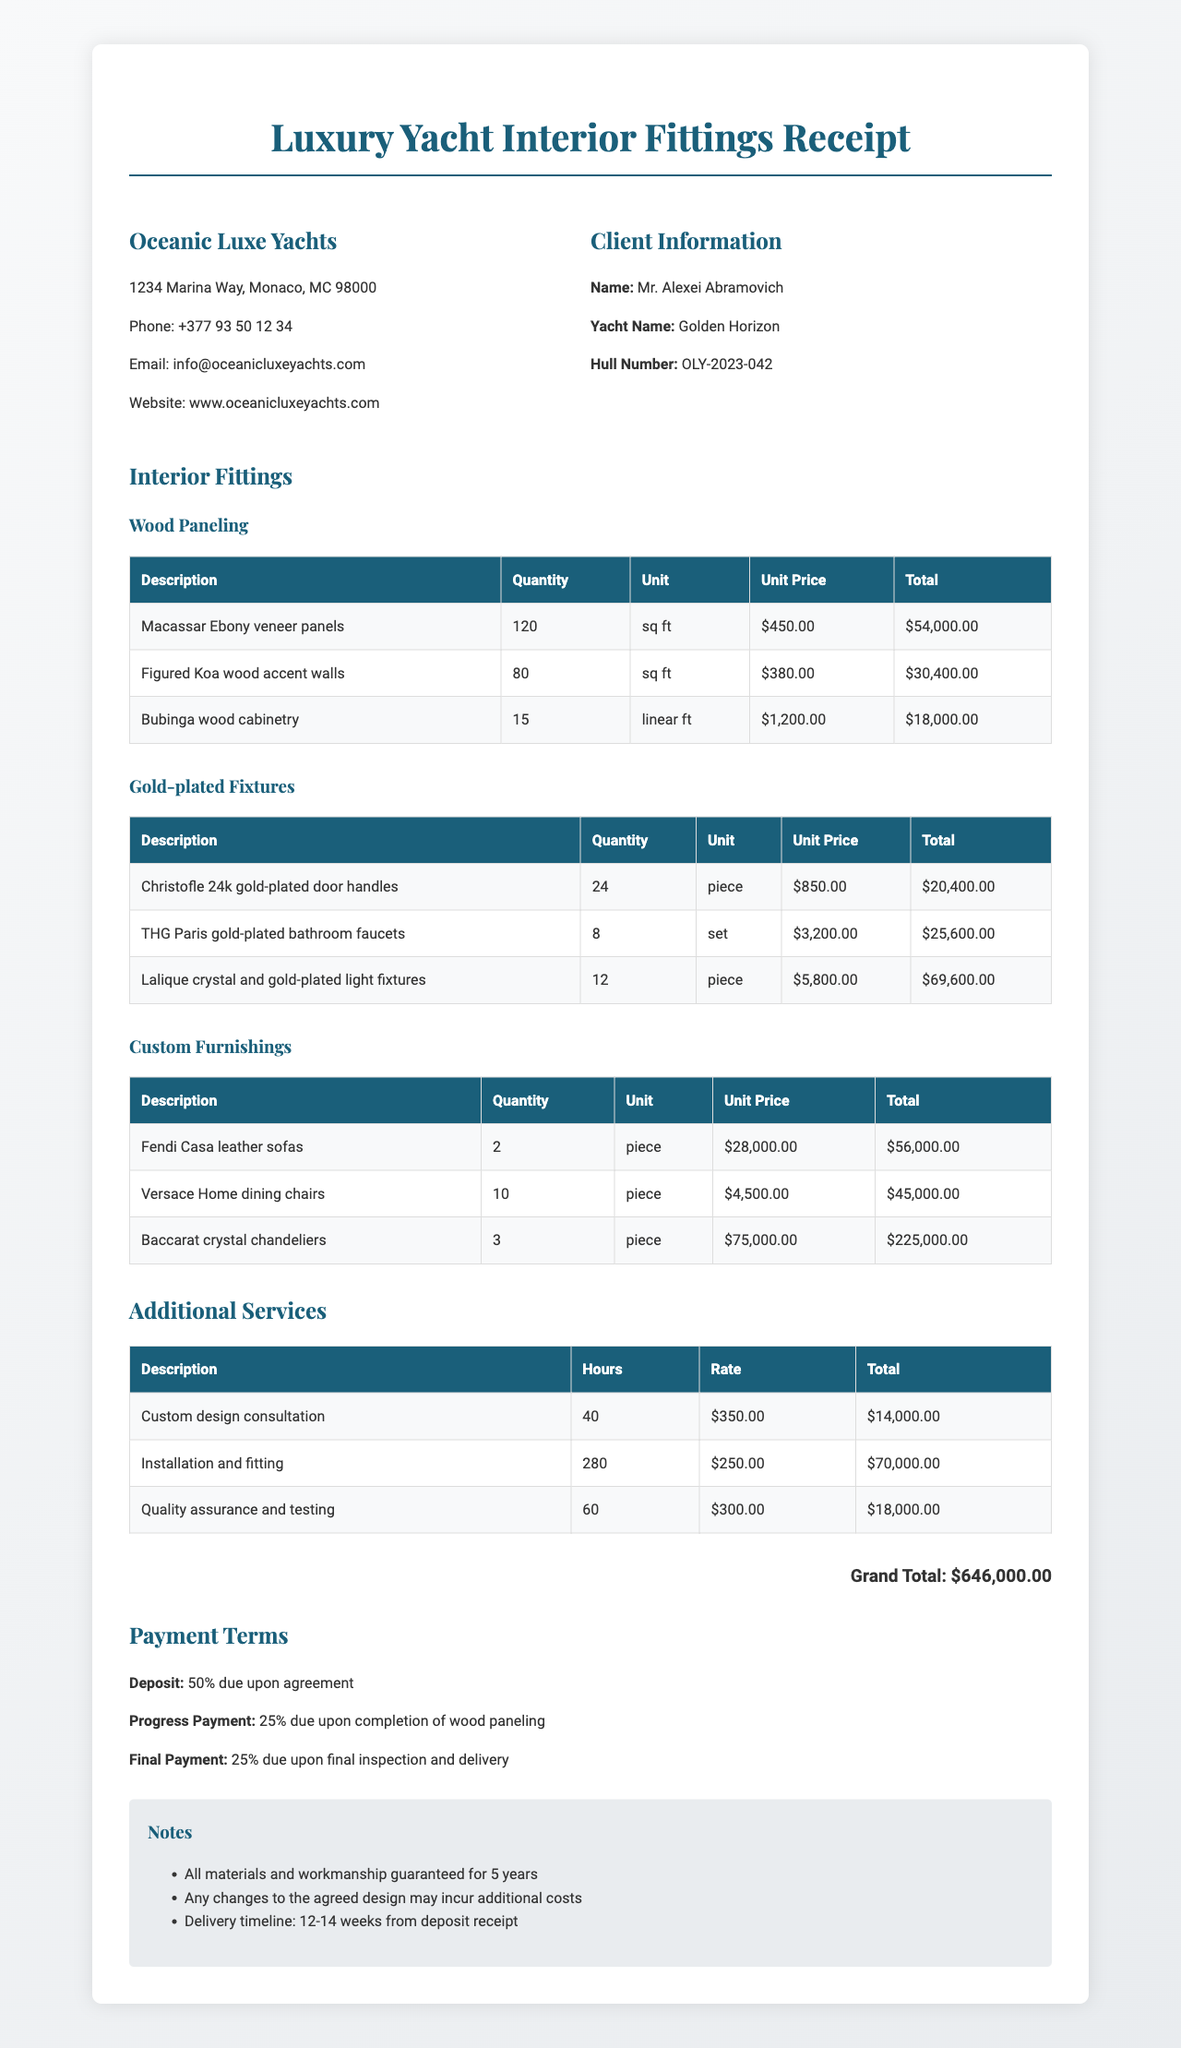What is the name of the yacht? The yacht name is specified in the client information section of the document.
Answer: Golden Horizon Who is the client? The client information provides the name of the individual associated with the purchase.
Answer: Mr. Alexei Abramovich What is the unit price of Macassar Ebony veneer panels? The document lists unit prices for each item, including the Macassar Ebony veneer panels.
Answer: $450 How many pieces of Christofle gold-plated door handles were ordered? The order details for each item include quantities, and Christofle door handles are listed with their quantity.
Answer: 24 What is the total cost for Baccarat crystal chandeliers? The total for each item provides insight into the overall costs, including the Baccarat crystal chandeliers.
Answer: $225000 What percentage is due upon agreement as a deposit? Payment terms detail specific percentages for payments scheduled at different stages.
Answer: 50% How many hours were allocated for installation and fitting? Additional services detail job descriptions alongside the hours dedicated to each service.
Answer: 280 What type of wood is used for the accent walls? The description of the wood paneling specifies the type of material used for accent walls.
Answer: Figured Koa wood What is guaranteed for how many years? Notes section includes key warranty information.
Answer: 5 years 